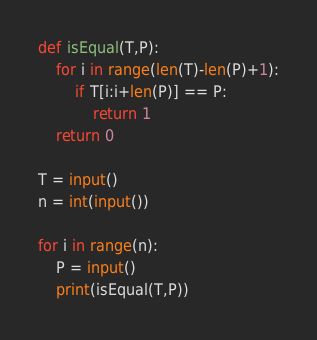Convert code to text. <code><loc_0><loc_0><loc_500><loc_500><_Python_>
def isEqual(T,P):
    for i in range(len(T)-len(P)+1):
        if T[i:i+len(P)] == P:
            return 1
    return 0

T = input()
n = int(input())

for i in range(n):
    P = input()
    print(isEqual(T,P))</code> 